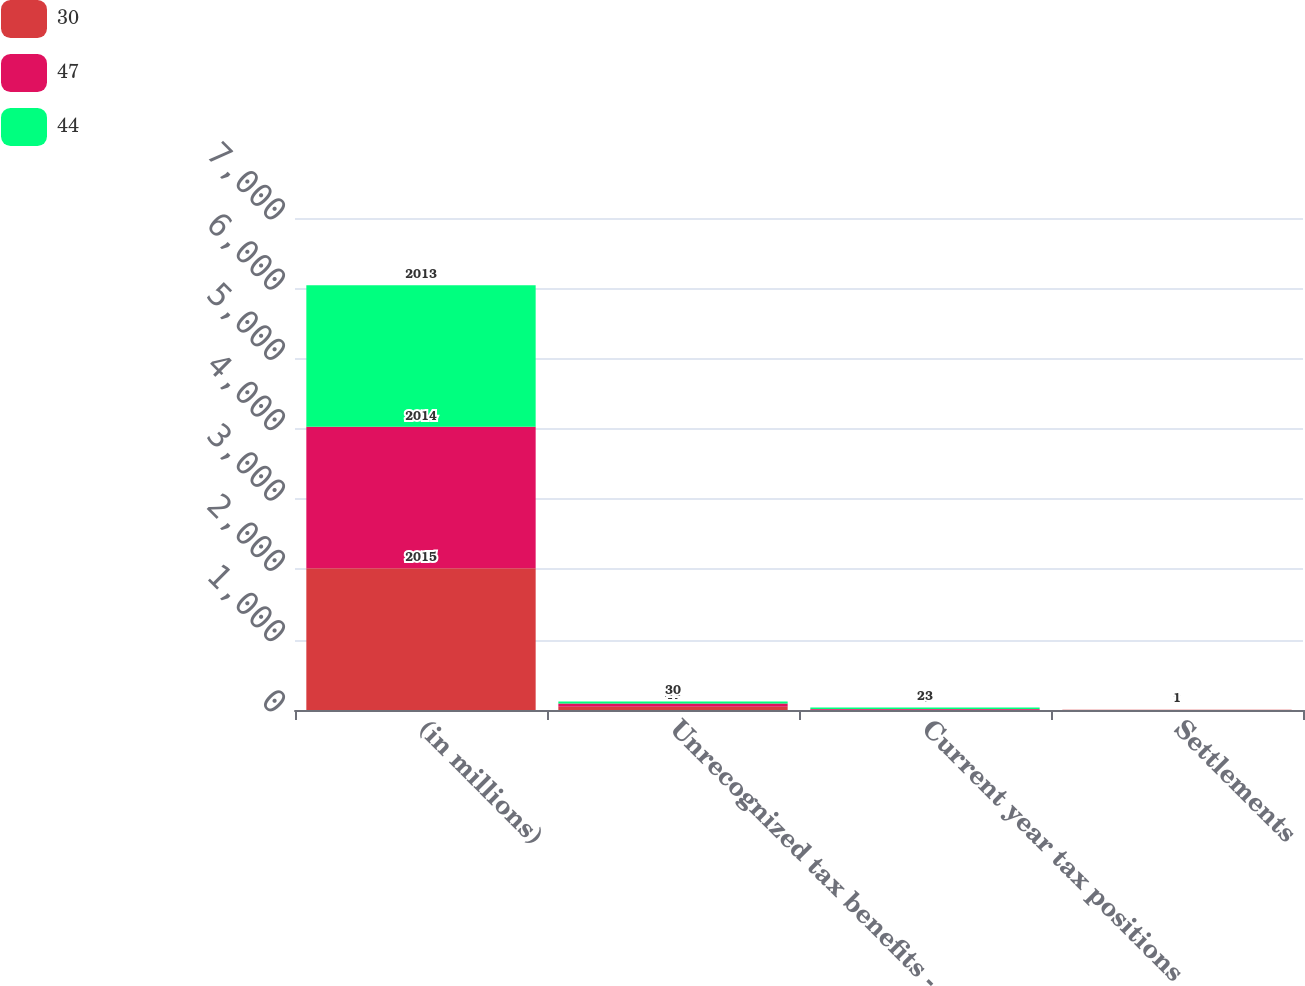Convert chart. <chart><loc_0><loc_0><loc_500><loc_500><stacked_bar_chart><ecel><fcel>(in millions)<fcel>Unrecognized tax benefits -<fcel>Current year tax positions<fcel>Settlements<nl><fcel>30<fcel>2015<fcel>47<fcel>4<fcel>2<nl><fcel>47<fcel>2014<fcel>44<fcel>9<fcel>2<nl><fcel>44<fcel>2013<fcel>30<fcel>23<fcel>1<nl></chart> 